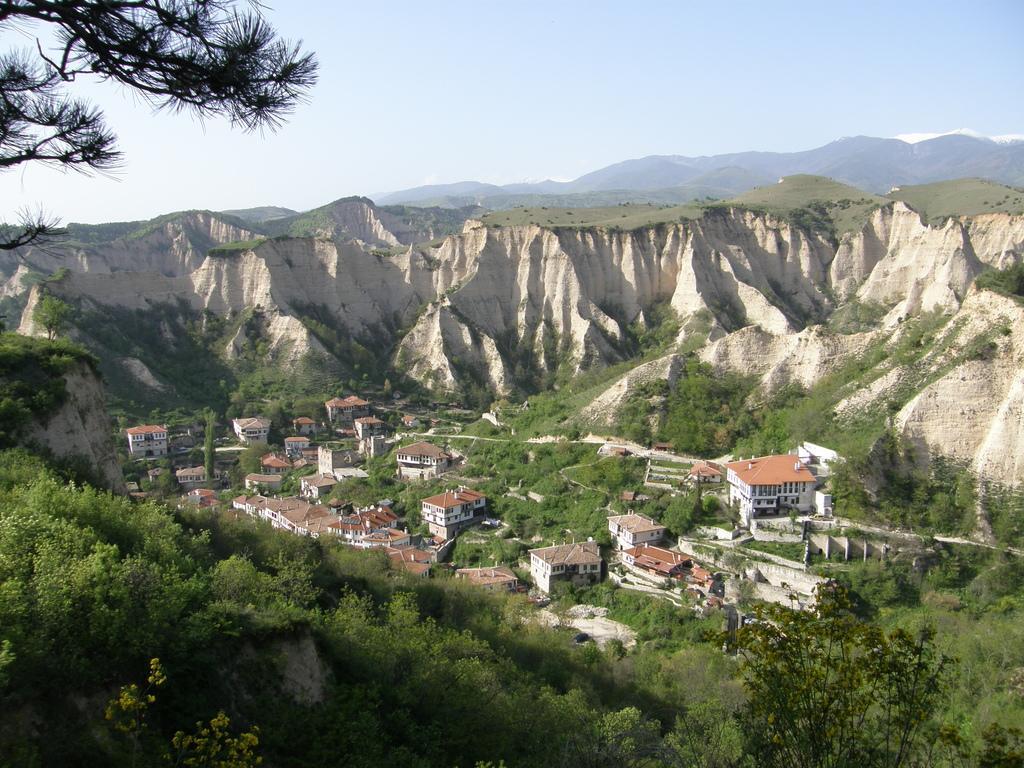In one or two sentences, can you explain what this image depicts? In this image we can see trees, buildings, mountains and sky. 